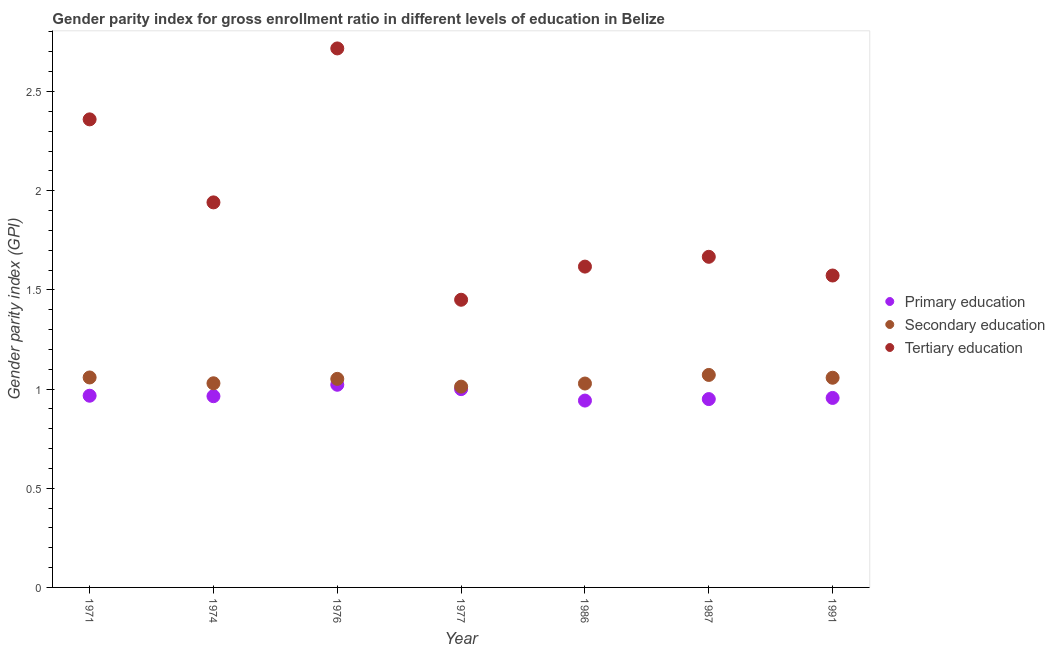Is the number of dotlines equal to the number of legend labels?
Provide a succinct answer. Yes. What is the gender parity index in tertiary education in 1977?
Make the answer very short. 1.45. Across all years, what is the maximum gender parity index in tertiary education?
Your answer should be very brief. 2.72. Across all years, what is the minimum gender parity index in primary education?
Ensure brevity in your answer.  0.94. In which year was the gender parity index in tertiary education maximum?
Ensure brevity in your answer.  1976. What is the total gender parity index in secondary education in the graph?
Your answer should be very brief. 7.31. What is the difference between the gender parity index in tertiary education in 1976 and that in 1987?
Give a very brief answer. 1.05. What is the difference between the gender parity index in secondary education in 1974 and the gender parity index in tertiary education in 1977?
Your answer should be compact. -0.42. What is the average gender parity index in secondary education per year?
Make the answer very short. 1.04. In the year 1987, what is the difference between the gender parity index in tertiary education and gender parity index in primary education?
Make the answer very short. 0.72. What is the ratio of the gender parity index in tertiary education in 1974 to that in 1991?
Provide a succinct answer. 1.23. Is the gender parity index in tertiary education in 1976 less than that in 1977?
Ensure brevity in your answer.  No. Is the difference between the gender parity index in tertiary education in 1986 and 1987 greater than the difference between the gender parity index in secondary education in 1986 and 1987?
Give a very brief answer. No. What is the difference between the highest and the second highest gender parity index in primary education?
Give a very brief answer. 0.02. What is the difference between the highest and the lowest gender parity index in tertiary education?
Offer a terse response. 1.27. Does the graph contain any zero values?
Provide a succinct answer. No. Where does the legend appear in the graph?
Your response must be concise. Center right. How are the legend labels stacked?
Give a very brief answer. Vertical. What is the title of the graph?
Give a very brief answer. Gender parity index for gross enrollment ratio in different levels of education in Belize. Does "Argument" appear as one of the legend labels in the graph?
Provide a succinct answer. No. What is the label or title of the X-axis?
Your response must be concise. Year. What is the label or title of the Y-axis?
Your answer should be compact. Gender parity index (GPI). What is the Gender parity index (GPI) in Primary education in 1971?
Give a very brief answer. 0.97. What is the Gender parity index (GPI) in Secondary education in 1971?
Give a very brief answer. 1.06. What is the Gender parity index (GPI) of Tertiary education in 1971?
Provide a succinct answer. 2.36. What is the Gender parity index (GPI) in Primary education in 1974?
Your answer should be very brief. 0.96. What is the Gender parity index (GPI) of Secondary education in 1974?
Your answer should be compact. 1.03. What is the Gender parity index (GPI) of Tertiary education in 1974?
Provide a succinct answer. 1.94. What is the Gender parity index (GPI) in Primary education in 1976?
Your answer should be compact. 1.02. What is the Gender parity index (GPI) of Secondary education in 1976?
Provide a short and direct response. 1.05. What is the Gender parity index (GPI) in Tertiary education in 1976?
Offer a very short reply. 2.72. What is the Gender parity index (GPI) in Primary education in 1977?
Your response must be concise. 1. What is the Gender parity index (GPI) in Secondary education in 1977?
Ensure brevity in your answer.  1.01. What is the Gender parity index (GPI) in Tertiary education in 1977?
Provide a succinct answer. 1.45. What is the Gender parity index (GPI) in Primary education in 1986?
Give a very brief answer. 0.94. What is the Gender parity index (GPI) in Secondary education in 1986?
Offer a terse response. 1.03. What is the Gender parity index (GPI) in Tertiary education in 1986?
Offer a terse response. 1.62. What is the Gender parity index (GPI) in Primary education in 1987?
Provide a succinct answer. 0.95. What is the Gender parity index (GPI) in Secondary education in 1987?
Keep it short and to the point. 1.07. What is the Gender parity index (GPI) in Tertiary education in 1987?
Keep it short and to the point. 1.67. What is the Gender parity index (GPI) of Primary education in 1991?
Your answer should be compact. 0.96. What is the Gender parity index (GPI) of Secondary education in 1991?
Provide a succinct answer. 1.06. What is the Gender parity index (GPI) of Tertiary education in 1991?
Offer a very short reply. 1.57. Across all years, what is the maximum Gender parity index (GPI) of Primary education?
Ensure brevity in your answer.  1.02. Across all years, what is the maximum Gender parity index (GPI) of Secondary education?
Make the answer very short. 1.07. Across all years, what is the maximum Gender parity index (GPI) in Tertiary education?
Offer a terse response. 2.72. Across all years, what is the minimum Gender parity index (GPI) in Primary education?
Your answer should be compact. 0.94. Across all years, what is the minimum Gender parity index (GPI) of Secondary education?
Offer a terse response. 1.01. Across all years, what is the minimum Gender parity index (GPI) in Tertiary education?
Offer a very short reply. 1.45. What is the total Gender parity index (GPI) in Primary education in the graph?
Your answer should be compact. 6.8. What is the total Gender parity index (GPI) of Secondary education in the graph?
Provide a short and direct response. 7.31. What is the total Gender parity index (GPI) of Tertiary education in the graph?
Offer a terse response. 13.32. What is the difference between the Gender parity index (GPI) of Primary education in 1971 and that in 1974?
Your response must be concise. 0. What is the difference between the Gender parity index (GPI) in Secondary education in 1971 and that in 1974?
Offer a terse response. 0.03. What is the difference between the Gender parity index (GPI) of Tertiary education in 1971 and that in 1974?
Ensure brevity in your answer.  0.42. What is the difference between the Gender parity index (GPI) of Primary education in 1971 and that in 1976?
Keep it short and to the point. -0.06. What is the difference between the Gender parity index (GPI) of Secondary education in 1971 and that in 1976?
Make the answer very short. 0.01. What is the difference between the Gender parity index (GPI) in Tertiary education in 1971 and that in 1976?
Offer a terse response. -0.36. What is the difference between the Gender parity index (GPI) of Primary education in 1971 and that in 1977?
Provide a short and direct response. -0.03. What is the difference between the Gender parity index (GPI) in Secondary education in 1971 and that in 1977?
Offer a very short reply. 0.05. What is the difference between the Gender parity index (GPI) of Tertiary education in 1971 and that in 1977?
Offer a terse response. 0.91. What is the difference between the Gender parity index (GPI) of Primary education in 1971 and that in 1986?
Make the answer very short. 0.02. What is the difference between the Gender parity index (GPI) in Secondary education in 1971 and that in 1986?
Offer a very short reply. 0.03. What is the difference between the Gender parity index (GPI) in Tertiary education in 1971 and that in 1986?
Offer a very short reply. 0.74. What is the difference between the Gender parity index (GPI) of Primary education in 1971 and that in 1987?
Ensure brevity in your answer.  0.02. What is the difference between the Gender parity index (GPI) of Secondary education in 1971 and that in 1987?
Your answer should be compact. -0.01. What is the difference between the Gender parity index (GPI) of Tertiary education in 1971 and that in 1987?
Provide a short and direct response. 0.69. What is the difference between the Gender parity index (GPI) in Primary education in 1971 and that in 1991?
Give a very brief answer. 0.01. What is the difference between the Gender parity index (GPI) in Secondary education in 1971 and that in 1991?
Provide a short and direct response. 0. What is the difference between the Gender parity index (GPI) of Tertiary education in 1971 and that in 1991?
Offer a terse response. 0.79. What is the difference between the Gender parity index (GPI) of Primary education in 1974 and that in 1976?
Your answer should be compact. -0.06. What is the difference between the Gender parity index (GPI) in Secondary education in 1974 and that in 1976?
Keep it short and to the point. -0.02. What is the difference between the Gender parity index (GPI) in Tertiary education in 1974 and that in 1976?
Provide a succinct answer. -0.78. What is the difference between the Gender parity index (GPI) in Primary education in 1974 and that in 1977?
Give a very brief answer. -0.04. What is the difference between the Gender parity index (GPI) in Secondary education in 1974 and that in 1977?
Offer a terse response. 0.02. What is the difference between the Gender parity index (GPI) of Tertiary education in 1974 and that in 1977?
Ensure brevity in your answer.  0.49. What is the difference between the Gender parity index (GPI) in Primary education in 1974 and that in 1986?
Offer a terse response. 0.02. What is the difference between the Gender parity index (GPI) of Secondary education in 1974 and that in 1986?
Your response must be concise. 0. What is the difference between the Gender parity index (GPI) in Tertiary education in 1974 and that in 1986?
Your answer should be very brief. 0.32. What is the difference between the Gender parity index (GPI) of Primary education in 1974 and that in 1987?
Offer a terse response. 0.01. What is the difference between the Gender parity index (GPI) in Secondary education in 1974 and that in 1987?
Your response must be concise. -0.04. What is the difference between the Gender parity index (GPI) of Tertiary education in 1974 and that in 1987?
Offer a very short reply. 0.27. What is the difference between the Gender parity index (GPI) of Primary education in 1974 and that in 1991?
Ensure brevity in your answer.  0.01. What is the difference between the Gender parity index (GPI) in Secondary education in 1974 and that in 1991?
Make the answer very short. -0.03. What is the difference between the Gender parity index (GPI) of Tertiary education in 1974 and that in 1991?
Make the answer very short. 0.37. What is the difference between the Gender parity index (GPI) of Primary education in 1976 and that in 1977?
Your answer should be compact. 0.02. What is the difference between the Gender parity index (GPI) of Secondary education in 1976 and that in 1977?
Your response must be concise. 0.04. What is the difference between the Gender parity index (GPI) of Tertiary education in 1976 and that in 1977?
Keep it short and to the point. 1.27. What is the difference between the Gender parity index (GPI) of Primary education in 1976 and that in 1986?
Your response must be concise. 0.08. What is the difference between the Gender parity index (GPI) of Secondary education in 1976 and that in 1986?
Offer a terse response. 0.02. What is the difference between the Gender parity index (GPI) of Tertiary education in 1976 and that in 1986?
Provide a succinct answer. 1.1. What is the difference between the Gender parity index (GPI) in Primary education in 1976 and that in 1987?
Your answer should be compact. 0.07. What is the difference between the Gender parity index (GPI) in Secondary education in 1976 and that in 1987?
Ensure brevity in your answer.  -0.02. What is the difference between the Gender parity index (GPI) of Tertiary education in 1976 and that in 1987?
Give a very brief answer. 1.05. What is the difference between the Gender parity index (GPI) in Primary education in 1976 and that in 1991?
Offer a terse response. 0.07. What is the difference between the Gender parity index (GPI) in Secondary education in 1976 and that in 1991?
Provide a succinct answer. -0.01. What is the difference between the Gender parity index (GPI) of Tertiary education in 1976 and that in 1991?
Your response must be concise. 1.14. What is the difference between the Gender parity index (GPI) of Primary education in 1977 and that in 1986?
Make the answer very short. 0.06. What is the difference between the Gender parity index (GPI) of Secondary education in 1977 and that in 1986?
Provide a succinct answer. -0.02. What is the difference between the Gender parity index (GPI) in Tertiary education in 1977 and that in 1986?
Your answer should be very brief. -0.17. What is the difference between the Gender parity index (GPI) in Primary education in 1977 and that in 1987?
Your answer should be very brief. 0.05. What is the difference between the Gender parity index (GPI) of Secondary education in 1977 and that in 1987?
Give a very brief answer. -0.06. What is the difference between the Gender parity index (GPI) of Tertiary education in 1977 and that in 1987?
Your answer should be compact. -0.22. What is the difference between the Gender parity index (GPI) of Primary education in 1977 and that in 1991?
Provide a short and direct response. 0.04. What is the difference between the Gender parity index (GPI) of Secondary education in 1977 and that in 1991?
Your answer should be compact. -0.04. What is the difference between the Gender parity index (GPI) in Tertiary education in 1977 and that in 1991?
Offer a terse response. -0.12. What is the difference between the Gender parity index (GPI) of Primary education in 1986 and that in 1987?
Keep it short and to the point. -0.01. What is the difference between the Gender parity index (GPI) of Secondary education in 1986 and that in 1987?
Your response must be concise. -0.04. What is the difference between the Gender parity index (GPI) in Tertiary education in 1986 and that in 1987?
Make the answer very short. -0.05. What is the difference between the Gender parity index (GPI) in Primary education in 1986 and that in 1991?
Provide a succinct answer. -0.01. What is the difference between the Gender parity index (GPI) in Secondary education in 1986 and that in 1991?
Offer a terse response. -0.03. What is the difference between the Gender parity index (GPI) of Tertiary education in 1986 and that in 1991?
Provide a short and direct response. 0.04. What is the difference between the Gender parity index (GPI) in Primary education in 1987 and that in 1991?
Give a very brief answer. -0.01. What is the difference between the Gender parity index (GPI) of Secondary education in 1987 and that in 1991?
Give a very brief answer. 0.01. What is the difference between the Gender parity index (GPI) of Tertiary education in 1987 and that in 1991?
Provide a short and direct response. 0.09. What is the difference between the Gender parity index (GPI) in Primary education in 1971 and the Gender parity index (GPI) in Secondary education in 1974?
Provide a succinct answer. -0.06. What is the difference between the Gender parity index (GPI) in Primary education in 1971 and the Gender parity index (GPI) in Tertiary education in 1974?
Provide a short and direct response. -0.97. What is the difference between the Gender parity index (GPI) of Secondary education in 1971 and the Gender parity index (GPI) of Tertiary education in 1974?
Give a very brief answer. -0.88. What is the difference between the Gender parity index (GPI) in Primary education in 1971 and the Gender parity index (GPI) in Secondary education in 1976?
Give a very brief answer. -0.09. What is the difference between the Gender parity index (GPI) of Primary education in 1971 and the Gender parity index (GPI) of Tertiary education in 1976?
Your response must be concise. -1.75. What is the difference between the Gender parity index (GPI) of Secondary education in 1971 and the Gender parity index (GPI) of Tertiary education in 1976?
Provide a succinct answer. -1.66. What is the difference between the Gender parity index (GPI) in Primary education in 1971 and the Gender parity index (GPI) in Secondary education in 1977?
Make the answer very short. -0.05. What is the difference between the Gender parity index (GPI) in Primary education in 1971 and the Gender parity index (GPI) in Tertiary education in 1977?
Your answer should be compact. -0.48. What is the difference between the Gender parity index (GPI) of Secondary education in 1971 and the Gender parity index (GPI) of Tertiary education in 1977?
Provide a short and direct response. -0.39. What is the difference between the Gender parity index (GPI) of Primary education in 1971 and the Gender parity index (GPI) of Secondary education in 1986?
Your answer should be compact. -0.06. What is the difference between the Gender parity index (GPI) in Primary education in 1971 and the Gender parity index (GPI) in Tertiary education in 1986?
Ensure brevity in your answer.  -0.65. What is the difference between the Gender parity index (GPI) in Secondary education in 1971 and the Gender parity index (GPI) in Tertiary education in 1986?
Ensure brevity in your answer.  -0.56. What is the difference between the Gender parity index (GPI) of Primary education in 1971 and the Gender parity index (GPI) of Secondary education in 1987?
Make the answer very short. -0.1. What is the difference between the Gender parity index (GPI) of Primary education in 1971 and the Gender parity index (GPI) of Tertiary education in 1987?
Make the answer very short. -0.7. What is the difference between the Gender parity index (GPI) in Secondary education in 1971 and the Gender parity index (GPI) in Tertiary education in 1987?
Provide a short and direct response. -0.61. What is the difference between the Gender parity index (GPI) in Primary education in 1971 and the Gender parity index (GPI) in Secondary education in 1991?
Provide a succinct answer. -0.09. What is the difference between the Gender parity index (GPI) of Primary education in 1971 and the Gender parity index (GPI) of Tertiary education in 1991?
Your answer should be very brief. -0.61. What is the difference between the Gender parity index (GPI) of Secondary education in 1971 and the Gender parity index (GPI) of Tertiary education in 1991?
Provide a short and direct response. -0.51. What is the difference between the Gender parity index (GPI) in Primary education in 1974 and the Gender parity index (GPI) in Secondary education in 1976?
Ensure brevity in your answer.  -0.09. What is the difference between the Gender parity index (GPI) of Primary education in 1974 and the Gender parity index (GPI) of Tertiary education in 1976?
Offer a very short reply. -1.75. What is the difference between the Gender parity index (GPI) in Secondary education in 1974 and the Gender parity index (GPI) in Tertiary education in 1976?
Your answer should be very brief. -1.69. What is the difference between the Gender parity index (GPI) of Primary education in 1974 and the Gender parity index (GPI) of Secondary education in 1977?
Provide a short and direct response. -0.05. What is the difference between the Gender parity index (GPI) of Primary education in 1974 and the Gender parity index (GPI) of Tertiary education in 1977?
Ensure brevity in your answer.  -0.49. What is the difference between the Gender parity index (GPI) of Secondary education in 1974 and the Gender parity index (GPI) of Tertiary education in 1977?
Offer a terse response. -0.42. What is the difference between the Gender parity index (GPI) in Primary education in 1974 and the Gender parity index (GPI) in Secondary education in 1986?
Keep it short and to the point. -0.06. What is the difference between the Gender parity index (GPI) of Primary education in 1974 and the Gender parity index (GPI) of Tertiary education in 1986?
Your answer should be very brief. -0.65. What is the difference between the Gender parity index (GPI) in Secondary education in 1974 and the Gender parity index (GPI) in Tertiary education in 1986?
Ensure brevity in your answer.  -0.59. What is the difference between the Gender parity index (GPI) in Primary education in 1974 and the Gender parity index (GPI) in Secondary education in 1987?
Keep it short and to the point. -0.11. What is the difference between the Gender parity index (GPI) in Primary education in 1974 and the Gender parity index (GPI) in Tertiary education in 1987?
Keep it short and to the point. -0.7. What is the difference between the Gender parity index (GPI) in Secondary education in 1974 and the Gender parity index (GPI) in Tertiary education in 1987?
Provide a succinct answer. -0.64. What is the difference between the Gender parity index (GPI) of Primary education in 1974 and the Gender parity index (GPI) of Secondary education in 1991?
Make the answer very short. -0.09. What is the difference between the Gender parity index (GPI) in Primary education in 1974 and the Gender parity index (GPI) in Tertiary education in 1991?
Your response must be concise. -0.61. What is the difference between the Gender parity index (GPI) of Secondary education in 1974 and the Gender parity index (GPI) of Tertiary education in 1991?
Make the answer very short. -0.54. What is the difference between the Gender parity index (GPI) of Primary education in 1976 and the Gender parity index (GPI) of Secondary education in 1977?
Make the answer very short. 0.01. What is the difference between the Gender parity index (GPI) of Primary education in 1976 and the Gender parity index (GPI) of Tertiary education in 1977?
Offer a very short reply. -0.43. What is the difference between the Gender parity index (GPI) in Secondary education in 1976 and the Gender parity index (GPI) in Tertiary education in 1977?
Your answer should be very brief. -0.4. What is the difference between the Gender parity index (GPI) in Primary education in 1976 and the Gender parity index (GPI) in Secondary education in 1986?
Make the answer very short. -0.01. What is the difference between the Gender parity index (GPI) of Primary education in 1976 and the Gender parity index (GPI) of Tertiary education in 1986?
Your response must be concise. -0.6. What is the difference between the Gender parity index (GPI) of Secondary education in 1976 and the Gender parity index (GPI) of Tertiary education in 1986?
Make the answer very short. -0.57. What is the difference between the Gender parity index (GPI) of Primary education in 1976 and the Gender parity index (GPI) of Secondary education in 1987?
Offer a terse response. -0.05. What is the difference between the Gender parity index (GPI) of Primary education in 1976 and the Gender parity index (GPI) of Tertiary education in 1987?
Offer a terse response. -0.65. What is the difference between the Gender parity index (GPI) of Secondary education in 1976 and the Gender parity index (GPI) of Tertiary education in 1987?
Offer a very short reply. -0.62. What is the difference between the Gender parity index (GPI) in Primary education in 1976 and the Gender parity index (GPI) in Secondary education in 1991?
Make the answer very short. -0.04. What is the difference between the Gender parity index (GPI) in Primary education in 1976 and the Gender parity index (GPI) in Tertiary education in 1991?
Provide a short and direct response. -0.55. What is the difference between the Gender parity index (GPI) of Secondary education in 1976 and the Gender parity index (GPI) of Tertiary education in 1991?
Your answer should be very brief. -0.52. What is the difference between the Gender parity index (GPI) in Primary education in 1977 and the Gender parity index (GPI) in Secondary education in 1986?
Ensure brevity in your answer.  -0.03. What is the difference between the Gender parity index (GPI) in Primary education in 1977 and the Gender parity index (GPI) in Tertiary education in 1986?
Give a very brief answer. -0.62. What is the difference between the Gender parity index (GPI) in Secondary education in 1977 and the Gender parity index (GPI) in Tertiary education in 1986?
Ensure brevity in your answer.  -0.61. What is the difference between the Gender parity index (GPI) of Primary education in 1977 and the Gender parity index (GPI) of Secondary education in 1987?
Keep it short and to the point. -0.07. What is the difference between the Gender parity index (GPI) of Primary education in 1977 and the Gender parity index (GPI) of Tertiary education in 1987?
Provide a short and direct response. -0.67. What is the difference between the Gender parity index (GPI) of Secondary education in 1977 and the Gender parity index (GPI) of Tertiary education in 1987?
Make the answer very short. -0.65. What is the difference between the Gender parity index (GPI) of Primary education in 1977 and the Gender parity index (GPI) of Secondary education in 1991?
Offer a very short reply. -0.06. What is the difference between the Gender parity index (GPI) of Primary education in 1977 and the Gender parity index (GPI) of Tertiary education in 1991?
Ensure brevity in your answer.  -0.57. What is the difference between the Gender parity index (GPI) of Secondary education in 1977 and the Gender parity index (GPI) of Tertiary education in 1991?
Offer a very short reply. -0.56. What is the difference between the Gender parity index (GPI) of Primary education in 1986 and the Gender parity index (GPI) of Secondary education in 1987?
Make the answer very short. -0.13. What is the difference between the Gender parity index (GPI) in Primary education in 1986 and the Gender parity index (GPI) in Tertiary education in 1987?
Your answer should be very brief. -0.72. What is the difference between the Gender parity index (GPI) of Secondary education in 1986 and the Gender parity index (GPI) of Tertiary education in 1987?
Provide a short and direct response. -0.64. What is the difference between the Gender parity index (GPI) of Primary education in 1986 and the Gender parity index (GPI) of Secondary education in 1991?
Your answer should be very brief. -0.12. What is the difference between the Gender parity index (GPI) of Primary education in 1986 and the Gender parity index (GPI) of Tertiary education in 1991?
Provide a short and direct response. -0.63. What is the difference between the Gender parity index (GPI) in Secondary education in 1986 and the Gender parity index (GPI) in Tertiary education in 1991?
Your answer should be compact. -0.54. What is the difference between the Gender parity index (GPI) in Primary education in 1987 and the Gender parity index (GPI) in Secondary education in 1991?
Offer a very short reply. -0.11. What is the difference between the Gender parity index (GPI) of Primary education in 1987 and the Gender parity index (GPI) of Tertiary education in 1991?
Keep it short and to the point. -0.62. What is the difference between the Gender parity index (GPI) in Secondary education in 1987 and the Gender parity index (GPI) in Tertiary education in 1991?
Your response must be concise. -0.5. What is the average Gender parity index (GPI) of Primary education per year?
Your answer should be very brief. 0.97. What is the average Gender parity index (GPI) in Secondary education per year?
Your answer should be compact. 1.04. What is the average Gender parity index (GPI) in Tertiary education per year?
Ensure brevity in your answer.  1.9. In the year 1971, what is the difference between the Gender parity index (GPI) of Primary education and Gender parity index (GPI) of Secondary education?
Ensure brevity in your answer.  -0.09. In the year 1971, what is the difference between the Gender parity index (GPI) in Primary education and Gender parity index (GPI) in Tertiary education?
Your answer should be very brief. -1.39. In the year 1971, what is the difference between the Gender parity index (GPI) of Secondary education and Gender parity index (GPI) of Tertiary education?
Offer a terse response. -1.3. In the year 1974, what is the difference between the Gender parity index (GPI) of Primary education and Gender parity index (GPI) of Secondary education?
Keep it short and to the point. -0.07. In the year 1974, what is the difference between the Gender parity index (GPI) in Primary education and Gender parity index (GPI) in Tertiary education?
Offer a terse response. -0.98. In the year 1974, what is the difference between the Gender parity index (GPI) of Secondary education and Gender parity index (GPI) of Tertiary education?
Your response must be concise. -0.91. In the year 1976, what is the difference between the Gender parity index (GPI) of Primary education and Gender parity index (GPI) of Secondary education?
Offer a terse response. -0.03. In the year 1976, what is the difference between the Gender parity index (GPI) in Primary education and Gender parity index (GPI) in Tertiary education?
Offer a terse response. -1.7. In the year 1976, what is the difference between the Gender parity index (GPI) in Secondary education and Gender parity index (GPI) in Tertiary education?
Offer a terse response. -1.67. In the year 1977, what is the difference between the Gender parity index (GPI) in Primary education and Gender parity index (GPI) in Secondary education?
Make the answer very short. -0.01. In the year 1977, what is the difference between the Gender parity index (GPI) in Primary education and Gender parity index (GPI) in Tertiary education?
Offer a very short reply. -0.45. In the year 1977, what is the difference between the Gender parity index (GPI) of Secondary education and Gender parity index (GPI) of Tertiary education?
Offer a terse response. -0.44. In the year 1986, what is the difference between the Gender parity index (GPI) in Primary education and Gender parity index (GPI) in Secondary education?
Make the answer very short. -0.09. In the year 1986, what is the difference between the Gender parity index (GPI) of Primary education and Gender parity index (GPI) of Tertiary education?
Your answer should be compact. -0.68. In the year 1986, what is the difference between the Gender parity index (GPI) in Secondary education and Gender parity index (GPI) in Tertiary education?
Your answer should be compact. -0.59. In the year 1987, what is the difference between the Gender parity index (GPI) of Primary education and Gender parity index (GPI) of Secondary education?
Provide a short and direct response. -0.12. In the year 1987, what is the difference between the Gender parity index (GPI) of Primary education and Gender parity index (GPI) of Tertiary education?
Your answer should be compact. -0.72. In the year 1987, what is the difference between the Gender parity index (GPI) of Secondary education and Gender parity index (GPI) of Tertiary education?
Offer a terse response. -0.6. In the year 1991, what is the difference between the Gender parity index (GPI) of Primary education and Gender parity index (GPI) of Secondary education?
Make the answer very short. -0.1. In the year 1991, what is the difference between the Gender parity index (GPI) of Primary education and Gender parity index (GPI) of Tertiary education?
Ensure brevity in your answer.  -0.62. In the year 1991, what is the difference between the Gender parity index (GPI) in Secondary education and Gender parity index (GPI) in Tertiary education?
Provide a succinct answer. -0.52. What is the ratio of the Gender parity index (GPI) of Primary education in 1971 to that in 1974?
Keep it short and to the point. 1. What is the ratio of the Gender parity index (GPI) in Secondary education in 1971 to that in 1974?
Ensure brevity in your answer.  1.03. What is the ratio of the Gender parity index (GPI) of Tertiary education in 1971 to that in 1974?
Provide a short and direct response. 1.22. What is the ratio of the Gender parity index (GPI) of Primary education in 1971 to that in 1976?
Give a very brief answer. 0.95. What is the ratio of the Gender parity index (GPI) in Tertiary education in 1971 to that in 1976?
Make the answer very short. 0.87. What is the ratio of the Gender parity index (GPI) of Primary education in 1971 to that in 1977?
Provide a short and direct response. 0.97. What is the ratio of the Gender parity index (GPI) of Secondary education in 1971 to that in 1977?
Keep it short and to the point. 1.05. What is the ratio of the Gender parity index (GPI) of Tertiary education in 1971 to that in 1977?
Offer a terse response. 1.63. What is the ratio of the Gender parity index (GPI) in Secondary education in 1971 to that in 1986?
Give a very brief answer. 1.03. What is the ratio of the Gender parity index (GPI) in Tertiary education in 1971 to that in 1986?
Offer a terse response. 1.46. What is the ratio of the Gender parity index (GPI) in Primary education in 1971 to that in 1987?
Your answer should be very brief. 1.02. What is the ratio of the Gender parity index (GPI) in Tertiary education in 1971 to that in 1987?
Your answer should be compact. 1.42. What is the ratio of the Gender parity index (GPI) of Primary education in 1971 to that in 1991?
Your answer should be very brief. 1.01. What is the ratio of the Gender parity index (GPI) in Secondary education in 1971 to that in 1991?
Offer a very short reply. 1. What is the ratio of the Gender parity index (GPI) in Tertiary education in 1971 to that in 1991?
Your answer should be compact. 1.5. What is the ratio of the Gender parity index (GPI) in Primary education in 1974 to that in 1976?
Provide a short and direct response. 0.94. What is the ratio of the Gender parity index (GPI) of Secondary education in 1974 to that in 1976?
Give a very brief answer. 0.98. What is the ratio of the Gender parity index (GPI) of Tertiary education in 1974 to that in 1976?
Provide a short and direct response. 0.71. What is the ratio of the Gender parity index (GPI) in Primary education in 1974 to that in 1977?
Make the answer very short. 0.96. What is the ratio of the Gender parity index (GPI) of Secondary education in 1974 to that in 1977?
Give a very brief answer. 1.02. What is the ratio of the Gender parity index (GPI) in Tertiary education in 1974 to that in 1977?
Your answer should be compact. 1.34. What is the ratio of the Gender parity index (GPI) of Primary education in 1974 to that in 1986?
Make the answer very short. 1.02. What is the ratio of the Gender parity index (GPI) in Tertiary education in 1974 to that in 1986?
Provide a short and direct response. 1.2. What is the ratio of the Gender parity index (GPI) of Primary education in 1974 to that in 1987?
Make the answer very short. 1.02. What is the ratio of the Gender parity index (GPI) of Secondary education in 1974 to that in 1987?
Make the answer very short. 0.96. What is the ratio of the Gender parity index (GPI) in Tertiary education in 1974 to that in 1987?
Your response must be concise. 1.16. What is the ratio of the Gender parity index (GPI) of Primary education in 1974 to that in 1991?
Make the answer very short. 1.01. What is the ratio of the Gender parity index (GPI) in Secondary education in 1974 to that in 1991?
Provide a succinct answer. 0.97. What is the ratio of the Gender parity index (GPI) of Tertiary education in 1974 to that in 1991?
Give a very brief answer. 1.23. What is the ratio of the Gender parity index (GPI) in Primary education in 1976 to that in 1977?
Your response must be concise. 1.02. What is the ratio of the Gender parity index (GPI) in Secondary education in 1976 to that in 1977?
Offer a terse response. 1.04. What is the ratio of the Gender parity index (GPI) of Tertiary education in 1976 to that in 1977?
Give a very brief answer. 1.87. What is the ratio of the Gender parity index (GPI) in Primary education in 1976 to that in 1986?
Your answer should be compact. 1.08. What is the ratio of the Gender parity index (GPI) in Secondary education in 1976 to that in 1986?
Provide a short and direct response. 1.02. What is the ratio of the Gender parity index (GPI) of Tertiary education in 1976 to that in 1986?
Ensure brevity in your answer.  1.68. What is the ratio of the Gender parity index (GPI) of Primary education in 1976 to that in 1987?
Provide a short and direct response. 1.08. What is the ratio of the Gender parity index (GPI) in Secondary education in 1976 to that in 1987?
Ensure brevity in your answer.  0.98. What is the ratio of the Gender parity index (GPI) of Tertiary education in 1976 to that in 1987?
Your answer should be compact. 1.63. What is the ratio of the Gender parity index (GPI) in Primary education in 1976 to that in 1991?
Your response must be concise. 1.07. What is the ratio of the Gender parity index (GPI) of Secondary education in 1976 to that in 1991?
Keep it short and to the point. 0.99. What is the ratio of the Gender parity index (GPI) of Tertiary education in 1976 to that in 1991?
Your response must be concise. 1.73. What is the ratio of the Gender parity index (GPI) of Primary education in 1977 to that in 1986?
Make the answer very short. 1.06. What is the ratio of the Gender parity index (GPI) in Secondary education in 1977 to that in 1986?
Your answer should be very brief. 0.98. What is the ratio of the Gender parity index (GPI) of Tertiary education in 1977 to that in 1986?
Give a very brief answer. 0.9. What is the ratio of the Gender parity index (GPI) of Primary education in 1977 to that in 1987?
Provide a succinct answer. 1.05. What is the ratio of the Gender parity index (GPI) of Secondary education in 1977 to that in 1987?
Ensure brevity in your answer.  0.94. What is the ratio of the Gender parity index (GPI) of Tertiary education in 1977 to that in 1987?
Your answer should be very brief. 0.87. What is the ratio of the Gender parity index (GPI) of Primary education in 1977 to that in 1991?
Give a very brief answer. 1.05. What is the ratio of the Gender parity index (GPI) in Secondary education in 1977 to that in 1991?
Your answer should be very brief. 0.96. What is the ratio of the Gender parity index (GPI) of Tertiary education in 1977 to that in 1991?
Provide a short and direct response. 0.92. What is the ratio of the Gender parity index (GPI) of Primary education in 1986 to that in 1987?
Offer a terse response. 0.99. What is the ratio of the Gender parity index (GPI) in Secondary education in 1986 to that in 1987?
Your response must be concise. 0.96. What is the ratio of the Gender parity index (GPI) of Tertiary education in 1986 to that in 1987?
Keep it short and to the point. 0.97. What is the ratio of the Gender parity index (GPI) of Primary education in 1986 to that in 1991?
Make the answer very short. 0.99. What is the ratio of the Gender parity index (GPI) of Secondary education in 1986 to that in 1991?
Offer a terse response. 0.97. What is the ratio of the Gender parity index (GPI) in Tertiary education in 1986 to that in 1991?
Your answer should be compact. 1.03. What is the ratio of the Gender parity index (GPI) of Secondary education in 1987 to that in 1991?
Your answer should be compact. 1.01. What is the ratio of the Gender parity index (GPI) in Tertiary education in 1987 to that in 1991?
Provide a short and direct response. 1.06. What is the difference between the highest and the second highest Gender parity index (GPI) in Primary education?
Provide a short and direct response. 0.02. What is the difference between the highest and the second highest Gender parity index (GPI) in Secondary education?
Ensure brevity in your answer.  0.01. What is the difference between the highest and the second highest Gender parity index (GPI) in Tertiary education?
Your answer should be compact. 0.36. What is the difference between the highest and the lowest Gender parity index (GPI) of Primary education?
Provide a short and direct response. 0.08. What is the difference between the highest and the lowest Gender parity index (GPI) in Secondary education?
Your answer should be very brief. 0.06. What is the difference between the highest and the lowest Gender parity index (GPI) of Tertiary education?
Your answer should be very brief. 1.27. 